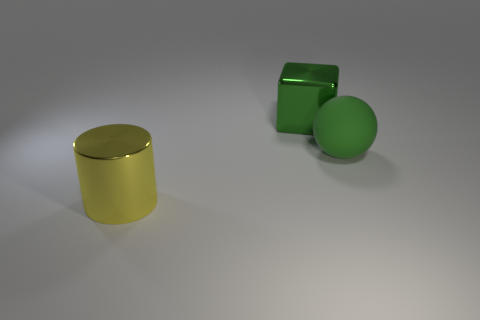What is the material of the other large thing that is the same color as the large rubber thing?
Give a very brief answer. Metal. Is there any other thing that has the same shape as the green metal thing?
Keep it short and to the point. No. There is a large object that is both behind the big cylinder and on the left side of the large green sphere; what is its shape?
Provide a short and direct response. Cube. There is a shiny cylinder; is its size the same as the green object left of the big matte ball?
Your response must be concise. Yes. There is a metallic object in front of the big block; is it the same size as the metallic object behind the big yellow object?
Offer a very short reply. Yes. Do the yellow metal object and the matte object have the same shape?
Keep it short and to the point. No. How many things are large shiny things behind the yellow metal cylinder or big yellow metal things?
Offer a terse response. 2. Are there the same number of yellow objects right of the metal cylinder and tiny yellow shiny cylinders?
Offer a terse response. Yes. What is the shape of the big metal object that is the same color as the sphere?
Ensure brevity in your answer.  Cube. How many green rubber things are the same size as the green matte sphere?
Provide a succinct answer. 0. 